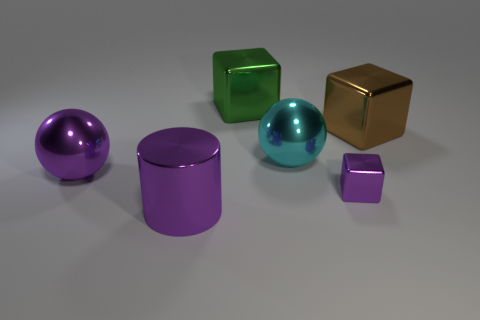How many things are either objects that are on the right side of the green thing or brown metal objects?
Provide a succinct answer. 3. Is the number of big purple things that are behind the green shiny cube greater than the number of big cylinders that are behind the big brown thing?
Offer a very short reply. No. What number of spheres are either large cyan things or big purple things?
Your response must be concise. 2. What number of large brown things are on the left side of the large ball right of the large purple thing behind the purple cylinder?
Offer a terse response. 0. There is a big object that is the same color as the big metallic cylinder; what is it made of?
Offer a terse response. Metal. Are there more big brown rubber spheres than cyan balls?
Make the answer very short. No. Is the size of the metallic cylinder the same as the brown metal thing?
Your answer should be very brief. Yes. What number of objects are either big cubes or green shiny blocks?
Your answer should be very brief. 2. What is the shape of the big object that is on the right side of the metallic cube in front of the big metallic object that is left of the purple cylinder?
Your response must be concise. Cube. Is the cyan sphere behind the large purple shiny ball made of the same material as the big purple thing on the left side of the big metallic cylinder?
Ensure brevity in your answer.  Yes. 